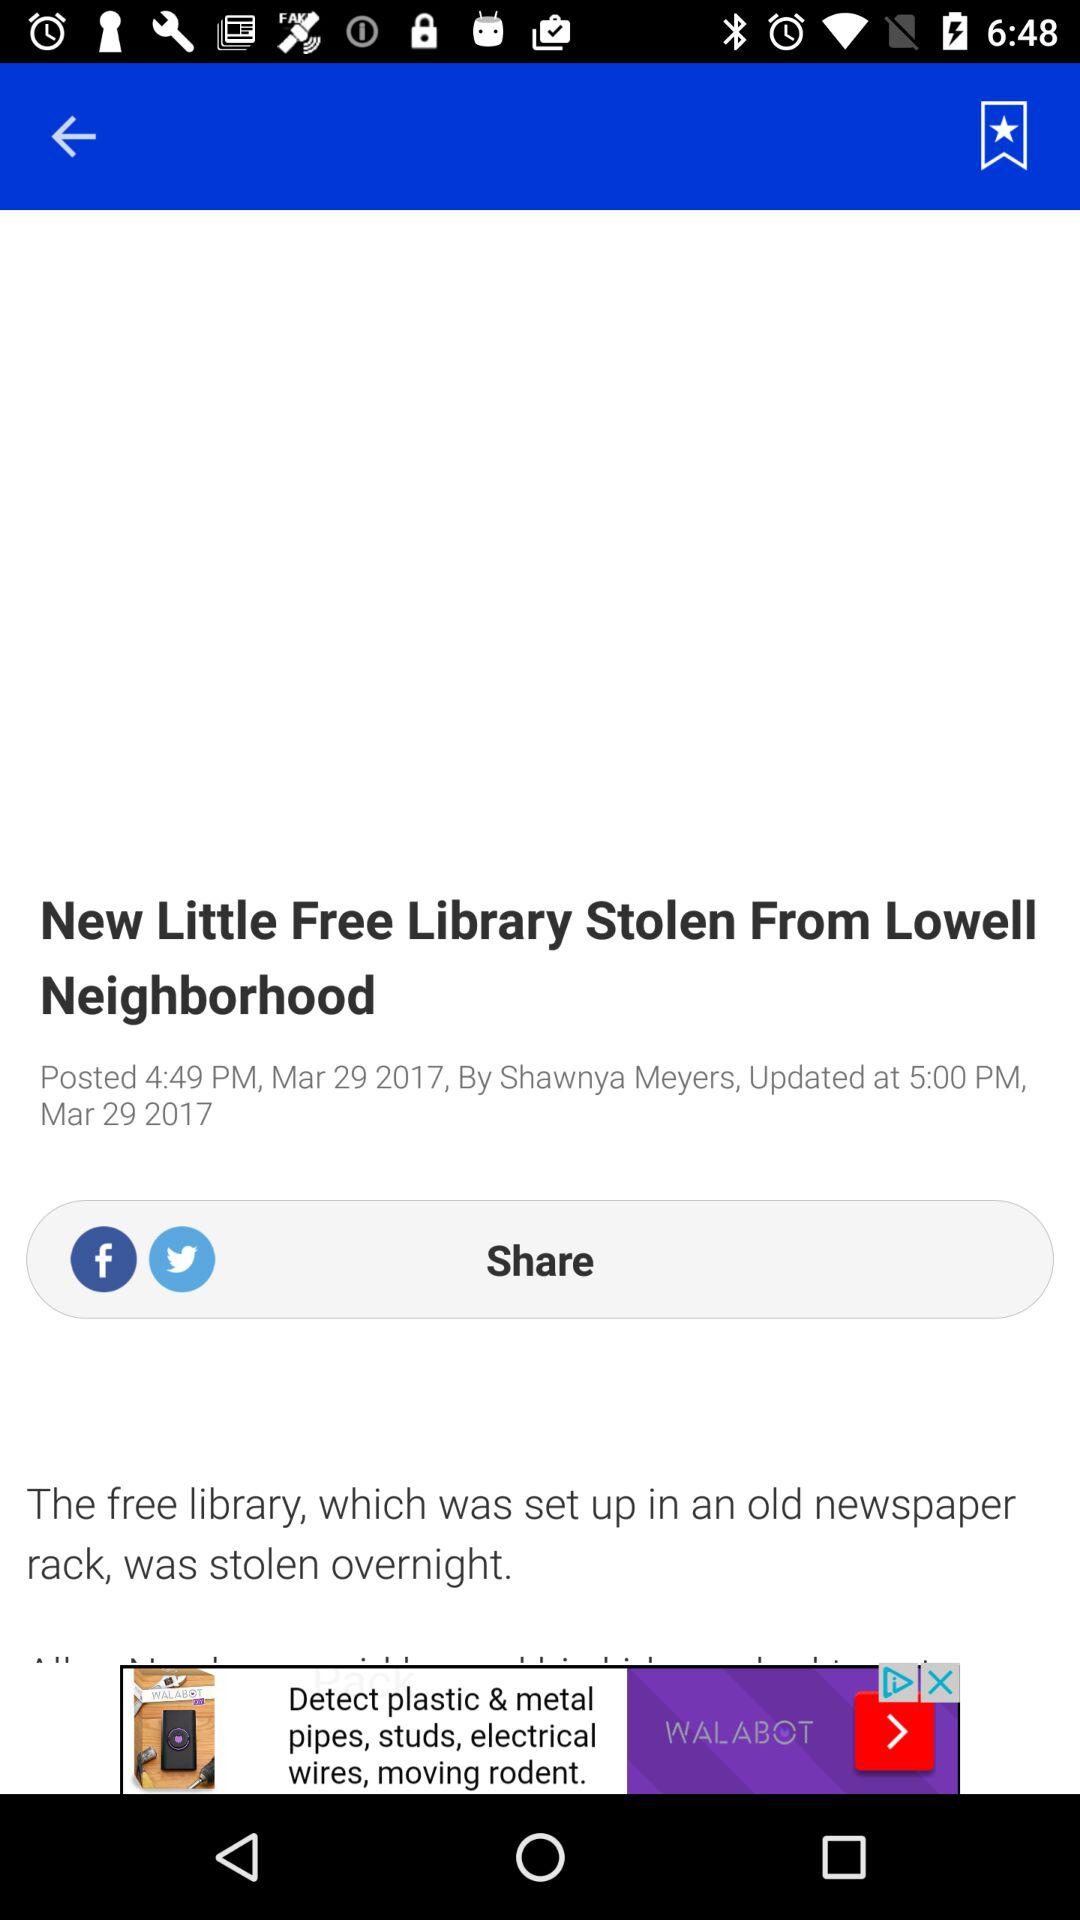What is the posted date of the article "New Little Free Library Stolen From Lowell Neighborhood"? The posted date of the article is March 29, 2017. 